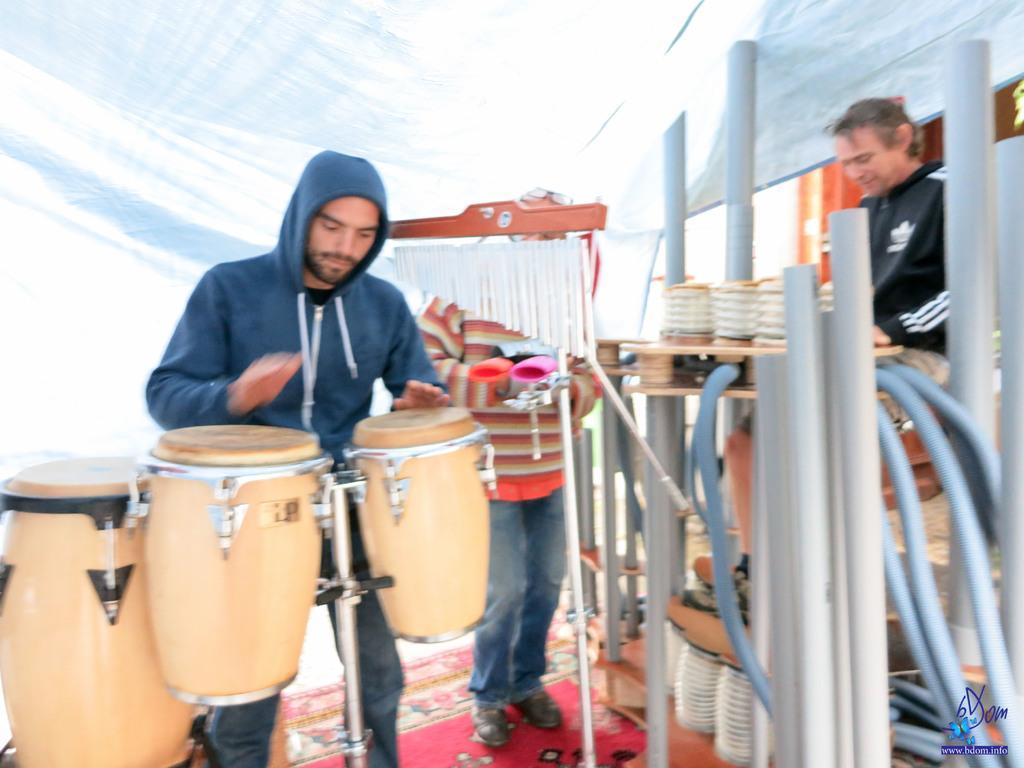In one or two sentences, can you explain what this image depicts? In this image there are three persons who are playing musical instruments at the left side of the image there is a person who is beating drums and at the right side of the image there is a person wearing black color dress playing musical instruments. 